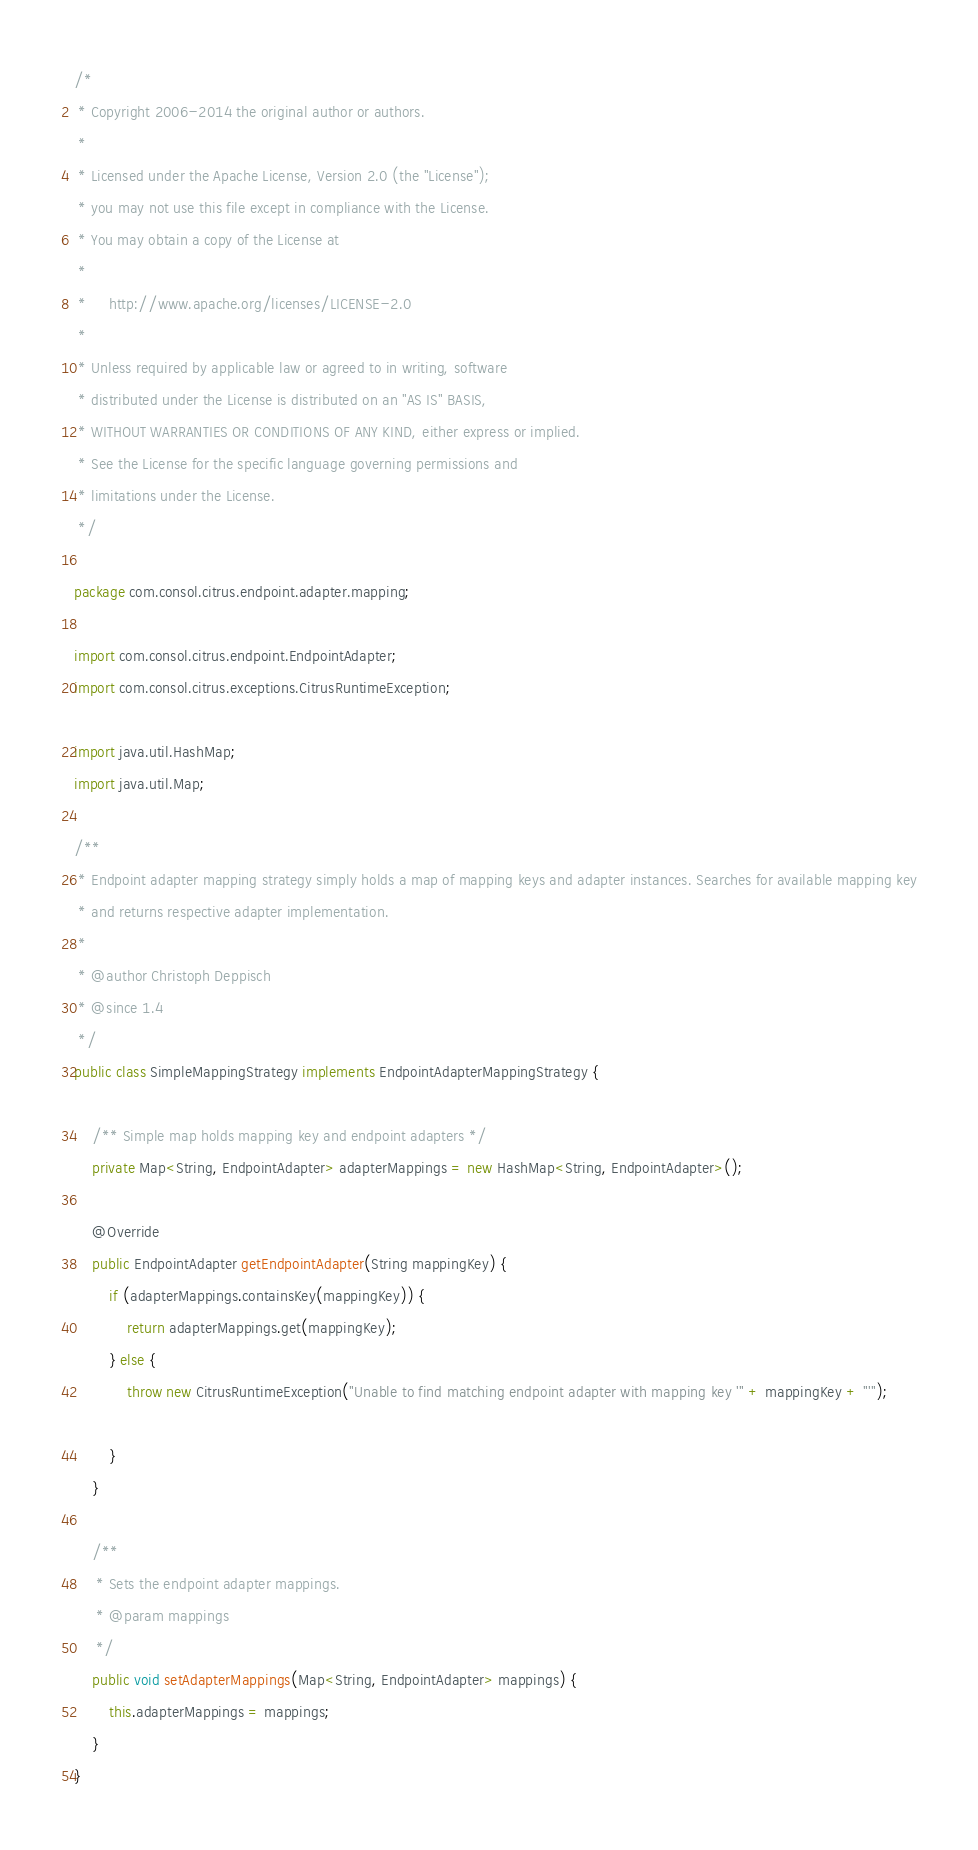<code> <loc_0><loc_0><loc_500><loc_500><_Java_>/*
 * Copyright 2006-2014 the original author or authors.
 *
 * Licensed under the Apache License, Version 2.0 (the "License");
 * you may not use this file except in compliance with the License.
 * You may obtain a copy of the License at
 *
 *     http://www.apache.org/licenses/LICENSE-2.0
 *
 * Unless required by applicable law or agreed to in writing, software
 * distributed under the License is distributed on an "AS IS" BASIS,
 * WITHOUT WARRANTIES OR CONDITIONS OF ANY KIND, either express or implied.
 * See the License for the specific language governing permissions and
 * limitations under the License.
 */

package com.consol.citrus.endpoint.adapter.mapping;

import com.consol.citrus.endpoint.EndpointAdapter;
import com.consol.citrus.exceptions.CitrusRuntimeException;

import java.util.HashMap;
import java.util.Map;

/**
 * Endpoint adapter mapping strategy simply holds a map of mapping keys and adapter instances. Searches for available mapping key
 * and returns respective adapter implementation.
 *
 * @author Christoph Deppisch
 * @since 1.4
 */
public class SimpleMappingStrategy implements EndpointAdapterMappingStrategy {

    /** Simple map holds mapping key and endpoint adapters */
    private Map<String, EndpointAdapter> adapterMappings = new HashMap<String, EndpointAdapter>();

    @Override
    public EndpointAdapter getEndpointAdapter(String mappingKey) {
        if (adapterMappings.containsKey(mappingKey)) {
            return adapterMappings.get(mappingKey);
        } else {
            throw new CitrusRuntimeException("Unable to find matching endpoint adapter with mapping key '" + mappingKey + "'");

        }
    }

    /**
     * Sets the endpoint adapter mappings.
     * @param mappings
     */
    public void setAdapterMappings(Map<String, EndpointAdapter> mappings) {
        this.adapterMappings = mappings;
    }
}
</code> 